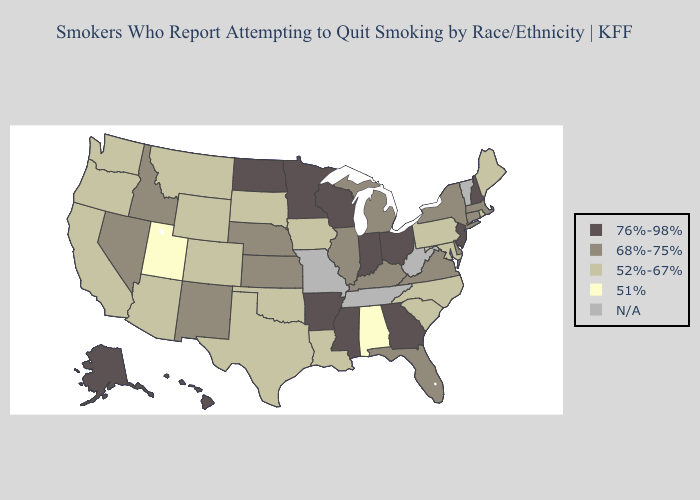What is the lowest value in the USA?
Write a very short answer. 51%. What is the lowest value in the MidWest?
Write a very short answer. 52%-67%. Does South Dakota have the highest value in the USA?
Quick response, please. No. What is the highest value in the West ?
Answer briefly. 76%-98%. What is the value of Rhode Island?
Short answer required. 52%-67%. How many symbols are there in the legend?
Quick response, please. 5. How many symbols are there in the legend?
Give a very brief answer. 5. What is the highest value in the Northeast ?
Concise answer only. 76%-98%. What is the value of Arizona?
Keep it brief. 52%-67%. Among the states that border Wyoming , which have the highest value?
Give a very brief answer. Idaho, Nebraska. Does Arkansas have the highest value in the USA?
Give a very brief answer. Yes. What is the value of Arizona?
Short answer required. 52%-67%. What is the value of Ohio?
Concise answer only. 76%-98%. Name the states that have a value in the range N/A?
Concise answer only. Missouri, Tennessee, Vermont, West Virginia. What is the lowest value in states that border South Carolina?
Keep it brief. 52%-67%. 